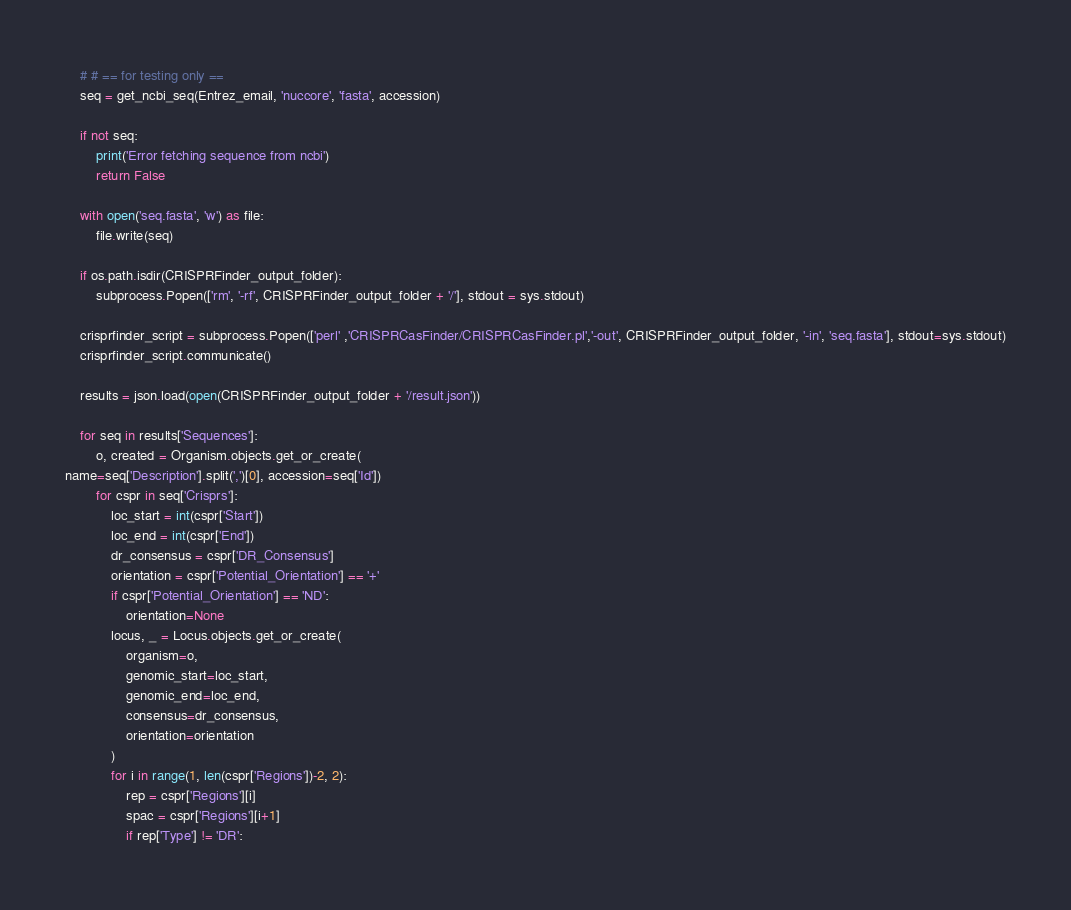Convert code to text. <code><loc_0><loc_0><loc_500><loc_500><_Python_>    # # == for testing only ==
    seq = get_ncbi_seq(Entrez_email, 'nuccore', 'fasta', accession)

    if not seq:
        print('Error fetching sequence from ncbi')
        return False

    with open('seq.fasta', 'w') as file:
        file.write(seq)

    if os.path.isdir(CRISPRFinder_output_folder):
        subprocess.Popen(['rm', '-rf', CRISPRFinder_output_folder + '/'], stdout = sys.stdout)

    crisprfinder_script = subprocess.Popen(['perl' ,'CRISPRCasFinder/CRISPRCasFinder.pl','-out', CRISPRFinder_output_folder, '-in', 'seq.fasta'], stdout=sys.stdout)
    crisprfinder_script.communicate()

    results = json.load(open(CRISPRFinder_output_folder + '/result.json'))

    for seq in results['Sequences']:
        o, created = Organism.objects.get_or_create(
name=seq['Description'].split(',')[0], accession=seq['Id'])
        for cspr in seq['Crisprs']:
            loc_start = int(cspr['Start'])
            loc_end = int(cspr['End'])
            dr_consensus = cspr['DR_Consensus']
            orientation = cspr['Potential_Orientation'] == '+'
            if cspr['Potential_Orientation'] == 'ND':
                orientation=None
            locus, _ = Locus.objects.get_or_create(
                organism=o,
                genomic_start=loc_start,
                genomic_end=loc_end,
                consensus=dr_consensus,
                orientation=orientation
            )
            for i in range(1, len(cspr['Regions'])-2, 2):
                rep = cspr['Regions'][i]
                spac = cspr['Regions'][i+1]
                if rep['Type'] != 'DR':</code> 